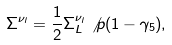<formula> <loc_0><loc_0><loc_500><loc_500>\Sigma ^ { \nu _ { l } } = \frac { 1 } { 2 } \Sigma _ { L } ^ { \nu _ { l } } \not p ( 1 - \gamma _ { 5 } ) ,</formula> 